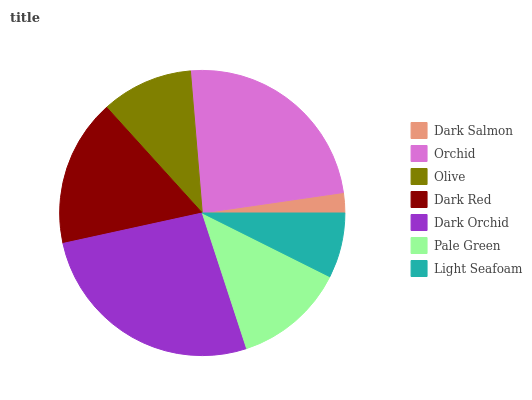Is Dark Salmon the minimum?
Answer yes or no. Yes. Is Dark Orchid the maximum?
Answer yes or no. Yes. Is Orchid the minimum?
Answer yes or no. No. Is Orchid the maximum?
Answer yes or no. No. Is Orchid greater than Dark Salmon?
Answer yes or no. Yes. Is Dark Salmon less than Orchid?
Answer yes or no. Yes. Is Dark Salmon greater than Orchid?
Answer yes or no. No. Is Orchid less than Dark Salmon?
Answer yes or no. No. Is Pale Green the high median?
Answer yes or no. Yes. Is Pale Green the low median?
Answer yes or no. Yes. Is Dark Salmon the high median?
Answer yes or no. No. Is Orchid the low median?
Answer yes or no. No. 